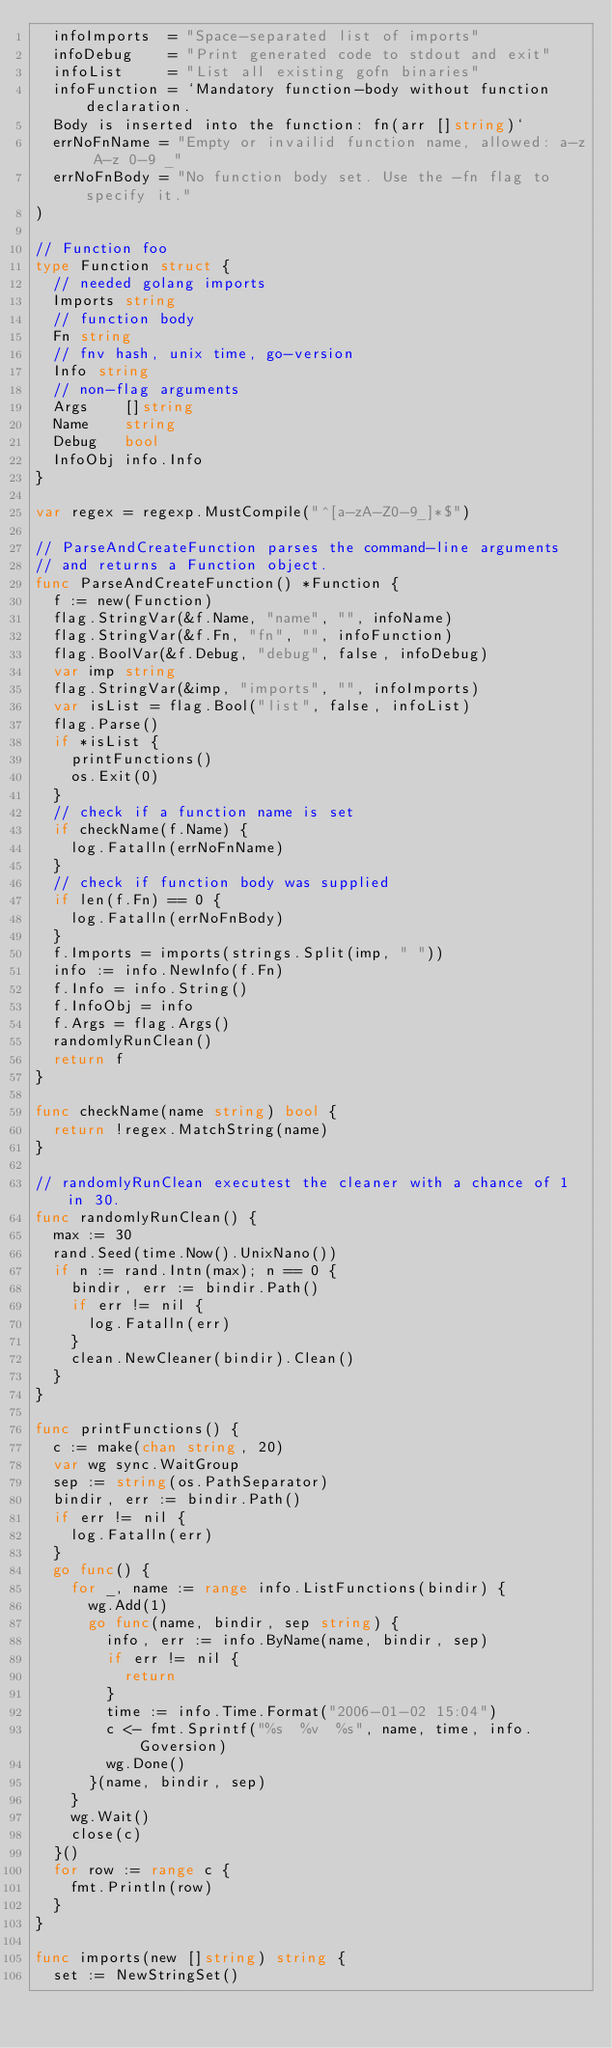Convert code to text. <code><loc_0><loc_0><loc_500><loc_500><_Go_>	infoImports  = "Space-separated list of imports"
	infoDebug    = "Print generated code to stdout and exit"
	infoList     = "List all existing gofn binaries"
	infoFunction = `Mandatory function-body without function declaration.
	Body is inserted into the function: fn(arr []string)`
	errNoFnName = "Empty or invailid function name, allowed: a-z A-z 0-9 _"
	errNoFnBody = "No function body set. Use the -fn flag to specify it."
)

// Function foo
type Function struct {
	// needed golang imports
	Imports string
	// function body
	Fn string
	// fnv hash, unix time, go-version
	Info string
	// non-flag arguments
	Args    []string
	Name    string
	Debug   bool
	InfoObj info.Info
}

var regex = regexp.MustCompile("^[a-zA-Z0-9_]*$")

// ParseAndCreateFunction parses the command-line arguments
// and returns a Function object.
func ParseAndCreateFunction() *Function {
	f := new(Function)
	flag.StringVar(&f.Name, "name", "", infoName)
	flag.StringVar(&f.Fn, "fn", "", infoFunction)
	flag.BoolVar(&f.Debug, "debug", false, infoDebug)
	var imp string
	flag.StringVar(&imp, "imports", "", infoImports)
	var isList = flag.Bool("list", false, infoList)
	flag.Parse()
	if *isList {
		printFunctions()
		os.Exit(0)
	}
	// check if a function name is set
	if checkName(f.Name) {
		log.Fatalln(errNoFnName)
	}
	// check if function body was supplied
	if len(f.Fn) == 0 {
		log.Fatalln(errNoFnBody)
	}
	f.Imports = imports(strings.Split(imp, " "))
	info := info.NewInfo(f.Fn)
	f.Info = info.String()
	f.InfoObj = info
	f.Args = flag.Args()
	randomlyRunClean()
	return f
}

func checkName(name string) bool {
	return !regex.MatchString(name)
}

// randomlyRunClean executest the cleaner with a chance of 1 in 30.
func randomlyRunClean() {
	max := 30
	rand.Seed(time.Now().UnixNano())
	if n := rand.Intn(max); n == 0 {
		bindir, err := bindir.Path()
		if err != nil {
			log.Fatalln(err)
		}
		clean.NewCleaner(bindir).Clean()
	}
}

func printFunctions() {
	c := make(chan string, 20)
	var wg sync.WaitGroup
	sep := string(os.PathSeparator)
	bindir, err := bindir.Path()
	if err != nil {
		log.Fatalln(err)
	}
	go func() {
		for _, name := range info.ListFunctions(bindir) {
			wg.Add(1)
			go func(name, bindir, sep string) {
				info, err := info.ByName(name, bindir, sep)
				if err != nil {
					return
				}
				time := info.Time.Format("2006-01-02 15:04")
				c <- fmt.Sprintf("%s  %v  %s", name, time, info.Goversion)
				wg.Done()
			}(name, bindir, sep)
		}
		wg.Wait()
		close(c)
	}()
	for row := range c {
		fmt.Println(row)
	}
}

func imports(new []string) string {
	set := NewStringSet()</code> 